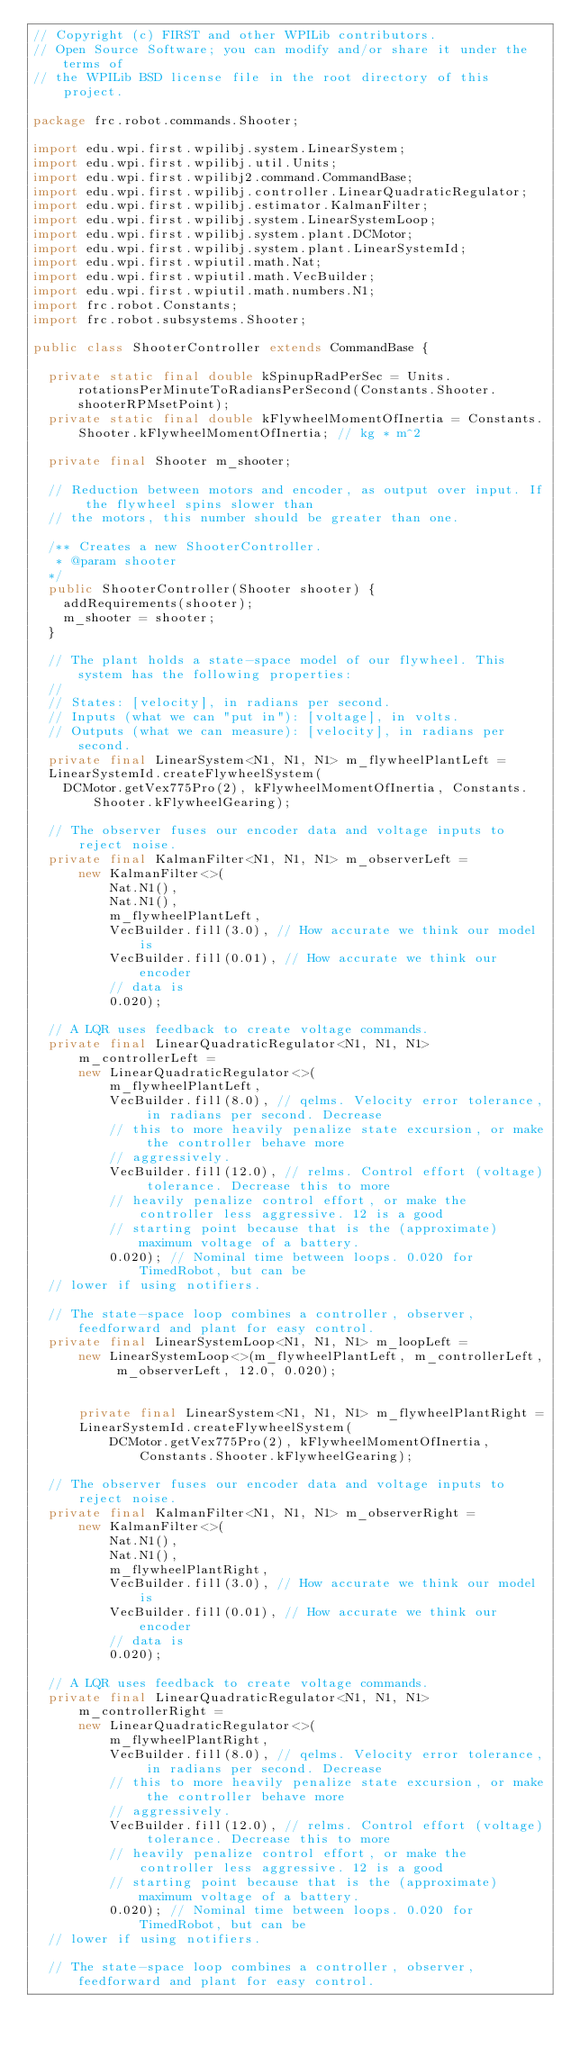Convert code to text. <code><loc_0><loc_0><loc_500><loc_500><_Java_>// Copyright (c) FIRST and other WPILib contributors.
// Open Source Software; you can modify and/or share it under the terms of
// the WPILib BSD license file in the root directory of this project.

package frc.robot.commands.Shooter;

import edu.wpi.first.wpilibj.system.LinearSystem;
import edu.wpi.first.wpilibj.util.Units;
import edu.wpi.first.wpilibj2.command.CommandBase;
import edu.wpi.first.wpilibj.controller.LinearQuadraticRegulator;
import edu.wpi.first.wpilibj.estimator.KalmanFilter;
import edu.wpi.first.wpilibj.system.LinearSystemLoop;
import edu.wpi.first.wpilibj.system.plant.DCMotor;
import edu.wpi.first.wpilibj.system.plant.LinearSystemId;
import edu.wpi.first.wpiutil.math.Nat;
import edu.wpi.first.wpiutil.math.VecBuilder;
import edu.wpi.first.wpiutil.math.numbers.N1;
import frc.robot.Constants;
import frc.robot.subsystems.Shooter;

public class ShooterController extends CommandBase {

  private static final double kSpinupRadPerSec = Units.rotationsPerMinuteToRadiansPerSecond(Constants.Shooter.shooterRPMsetPoint);
  private static final double kFlywheelMomentOfInertia = Constants.Shooter.kFlywheelMomentOfInertia; // kg * m^2

  private final Shooter m_shooter;
  
  // Reduction between motors and encoder, as output over input. If the flywheel spins slower than
  // the motors, this number should be greater than one.

  /** Creates a new ShooterController. 
   * @param shooter 
  */
  public ShooterController(Shooter shooter) {
    addRequirements(shooter);
    m_shooter = shooter;
  }
  
  // The plant holds a state-space model of our flywheel. This system has the following properties:
  //
  // States: [velocity], in radians per second.
  // Inputs (what we can "put in"): [voltage], in volts.
  // Outputs (what we can measure): [velocity], in radians per second.
  private final LinearSystem<N1, N1, N1> m_flywheelPlantLeft =
  LinearSystemId.createFlywheelSystem(
    DCMotor.getVex775Pro(2), kFlywheelMomentOfInertia, Constants.Shooter.kFlywheelGearing);

  // The observer fuses our encoder data and voltage inputs to reject noise.
  private final KalmanFilter<N1, N1, N1> m_observerLeft =
      new KalmanFilter<>(
          Nat.N1(),
          Nat.N1(),
          m_flywheelPlantLeft,
          VecBuilder.fill(3.0), // How accurate we think our model is
          VecBuilder.fill(0.01), // How accurate we think our encoder
          // data is
          0.020);

  // A LQR uses feedback to create voltage commands.
  private final LinearQuadraticRegulator<N1, N1, N1> m_controllerLeft =
      new LinearQuadraticRegulator<>(
          m_flywheelPlantLeft,
          VecBuilder.fill(8.0), // qelms. Velocity error tolerance, in radians per second. Decrease
          // this to more heavily penalize state excursion, or make the controller behave more
          // aggressively.
          VecBuilder.fill(12.0), // relms. Control effort (voltage) tolerance. Decrease this to more
          // heavily penalize control effort, or make the controller less aggressive. 12 is a good
          // starting point because that is the (approximate) maximum voltage of a battery.
          0.020); // Nominal time between loops. 0.020 for TimedRobot, but can be
  // lower if using notifiers.

  // The state-space loop combines a controller, observer, feedforward and plant for easy control.
  private final LinearSystemLoop<N1, N1, N1> m_loopLeft =
      new LinearSystemLoop<>(m_flywheelPlantLeft, m_controllerLeft, m_observerLeft, 12.0, 0.020);


      private final LinearSystem<N1, N1, N1> m_flywheelPlantRight =
      LinearSystemId.createFlywheelSystem(
          DCMotor.getVex775Pro(2), kFlywheelMomentOfInertia, Constants.Shooter.kFlywheelGearing);

  // The observer fuses our encoder data and voltage inputs to reject noise.
  private final KalmanFilter<N1, N1, N1> m_observerRight =
      new KalmanFilter<>(
          Nat.N1(),
          Nat.N1(),
          m_flywheelPlantRight,
          VecBuilder.fill(3.0), // How accurate we think our model is
          VecBuilder.fill(0.01), // How accurate we think our encoder
          // data is
          0.020);

  // A LQR uses feedback to create voltage commands.
  private final LinearQuadraticRegulator<N1, N1, N1> m_controllerRight =
      new LinearQuadraticRegulator<>(
          m_flywheelPlantRight,
          VecBuilder.fill(8.0), // qelms. Velocity error tolerance, in radians per second. Decrease
          // this to more heavily penalize state excursion, or make the controller behave more
          // aggressively.
          VecBuilder.fill(12.0), // relms. Control effort (voltage) tolerance. Decrease this to more
          // heavily penalize control effort, or make the controller less aggressive. 12 is a good
          // starting point because that is the (approximate) maximum voltage of a battery.
          0.020); // Nominal time between loops. 0.020 for TimedRobot, but can be
  // lower if using notifiers.

  // The state-space loop combines a controller, observer, feedforward and plant for easy control.</code> 